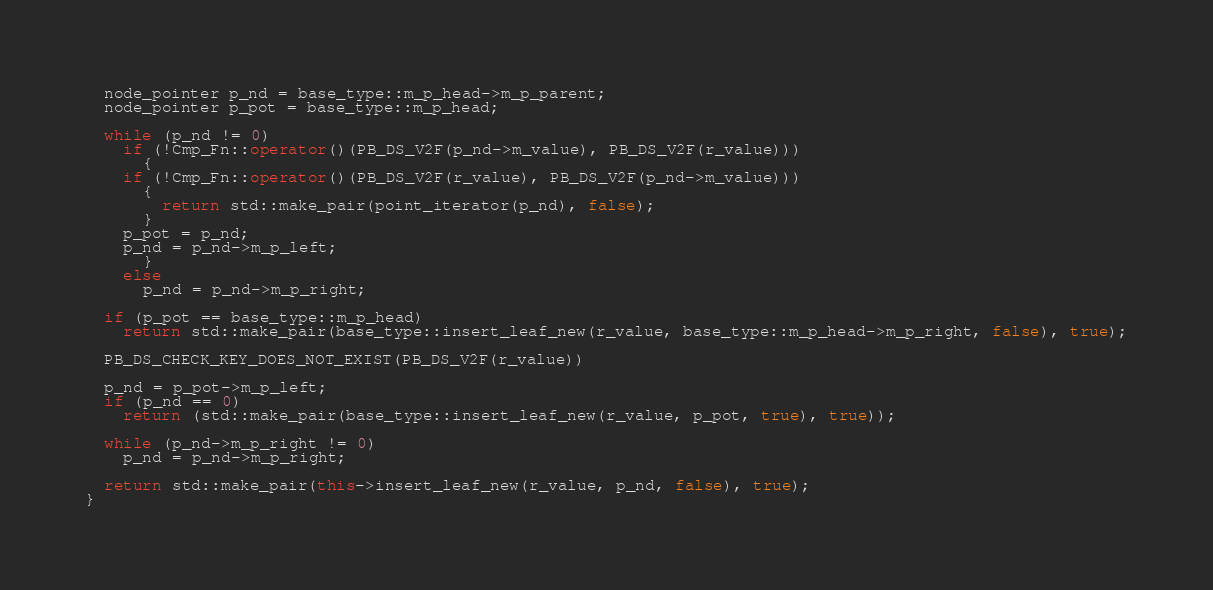<code> <loc_0><loc_0><loc_500><loc_500><_C++_>  node_pointer p_nd = base_type::m_p_head->m_p_parent;
  node_pointer p_pot = base_type::m_p_head;

  while (p_nd != 0)
    if (!Cmp_Fn::operator()(PB_DS_V2F(p_nd->m_value), PB_DS_V2F(r_value)))
      {
	if (!Cmp_Fn::operator()(PB_DS_V2F(r_value), PB_DS_V2F(p_nd->m_value)))
	  {
	    return std::make_pair(point_iterator(p_nd), false);
	  }
	p_pot = p_nd;
	p_nd = p_nd->m_p_left;
      }
    else
      p_nd = p_nd->m_p_right;

  if (p_pot == base_type::m_p_head)
    return std::make_pair(base_type::insert_leaf_new(r_value, base_type::m_p_head->m_p_right, false), true);

  PB_DS_CHECK_KEY_DOES_NOT_EXIST(PB_DS_V2F(r_value))

  p_nd = p_pot->m_p_left;
  if (p_nd == 0)
    return (std::make_pair(base_type::insert_leaf_new(r_value, p_pot, true), true));

  while (p_nd->m_p_right != 0)
    p_nd = p_nd->m_p_right;

  return std::make_pair(this->insert_leaf_new(r_value, p_nd, false), true);
}
</code> 